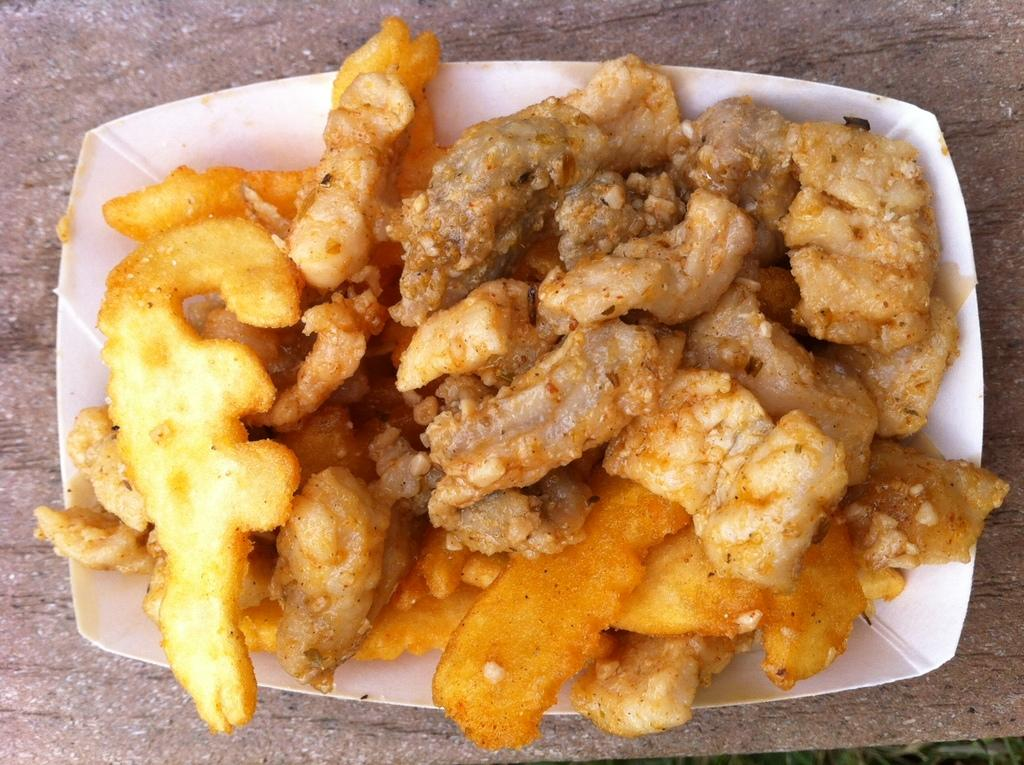What is in the bowl that is visible in the image? The bowl contains fried vegetables and meat. Where is the bowl located in the image? The bowl is placed on a table. In which setting is the image taken? The image is taken in a room. What type of animal is wearing shoes in the image? There is no animal wearing shoes in the image, as the image only features a bowl of fried vegetables and meat on a table in a room. 